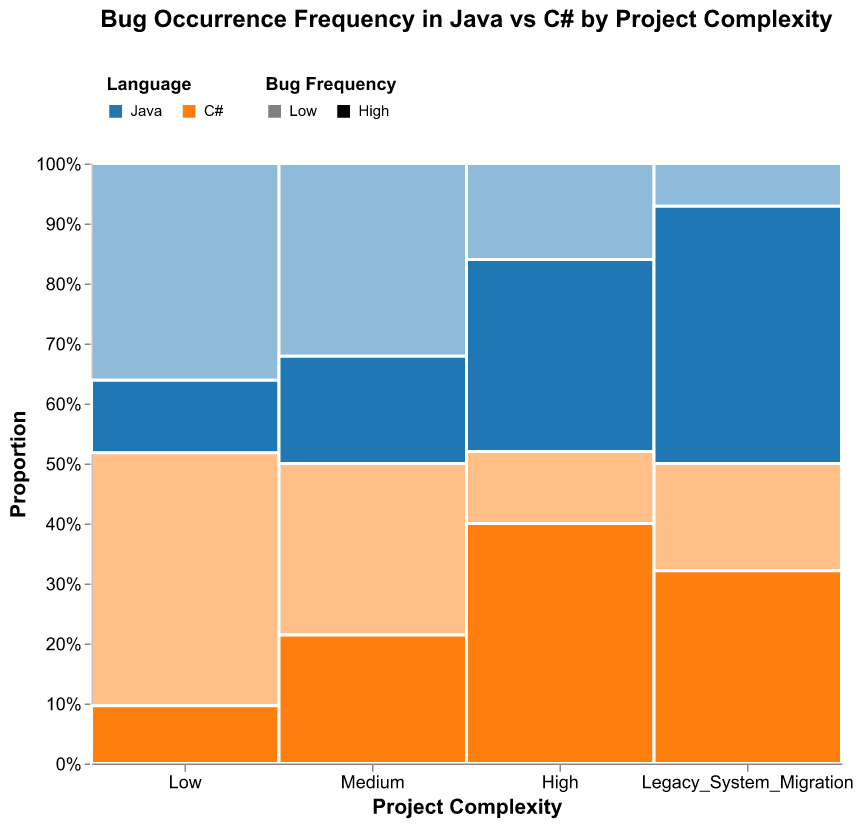What is the title of the plot? The title is usually displayed at the top of the figure in a bold and larger font, making it easily identifiable.
Answer: Bug Occurrence Frequency in Java vs C# by Project Complexity Which language has the highest bug frequency in high complexity projects? In high complexity projects, see which language's high bug frequency section is more prominent in the respective rectangular areas. Java's high bug frequency area is larger than C#'s in the high complexity section.
Answer: Java What is the bug frequency with the highest count for C# in legacy system migration projects? Check the relative sizes of the bars in the legacy system migration section for C#. The high bug frequency area for C# is the largest in this section.
Answer: High Are there more Low or High bug frequencies in Legacy System Migration for Java projects? Compare the size of the 'Low' and 'High' bug frequency areas for Java within the legacy system migration section. The 'High' area is significantly larger than the 'Low' area for Java in this particular section.
Answer: High In medium complexity projects, which language has a higher proportion of high bug frequency? Look at the medium complexity section and compare the sizes of the high bug frequency areas for both Java and C#. The high bug frequency area for C# is larger than that for Java.
Answer: C# How does the low bug frequency for C# compare between low and medium complexity projects? Compare the size of the 'Low' bug frequency sections for C# in both the low and medium complexity project sections. It is larger in the medium complexity projects.
Answer: Larger in medium complexity Which project complexity has the fewest overall bugs recorded for Java? Compare the total areas for Java in each project complexity section. The legacy system migration has fewer overall bugs recorded for Java compared to the others.
Answer: Legacy System Migration Calculate the total count of high bug frequency occurrences for Java across all projects. Java's high bug frequency counts are 10 (Low) + 25 (Medium) + 40 (High) + 60 (Legacy System Migration). The total is 135.
Answer: 135 Between Java and C#, which language shows a broader variance in bug frequency counts in medium complexity projects? In medium complexity projects, compare the differences in size between low and high bug frequency sections for both languages. Java has a broader spread between its low and high bug frequency counts than C#.
Answer: Java 